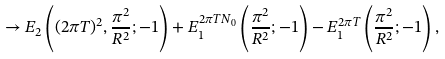Convert formula to latex. <formula><loc_0><loc_0><loc_500><loc_500>\rightarrow E _ { 2 } \left ( ( 2 \pi T ) ^ { 2 } , \frac { \pi ^ { 2 } } { R ^ { 2 } } ; - 1 \right ) + E _ { 1 } ^ { 2 \pi T N _ { 0 } } \left ( \frac { \pi ^ { 2 } } { R ^ { 2 } } ; - 1 \right ) - E _ { 1 } ^ { 2 \pi T } \left ( \frac { \pi ^ { 2 } } { R ^ { 2 } } ; - 1 \right ) ,</formula> 